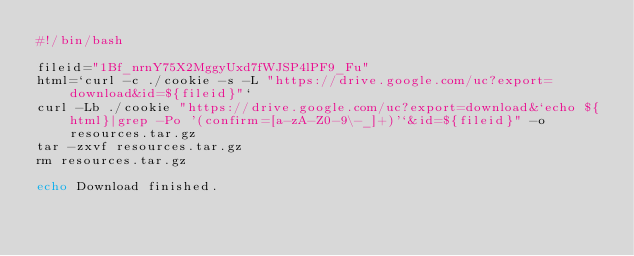<code> <loc_0><loc_0><loc_500><loc_500><_Bash_>#!/bin/bash

fileid="1Bf_nrnY75X2MggyUxd7fWJSP4lPF9_Fu"
html=`curl -c ./cookie -s -L "https://drive.google.com/uc?export=download&id=${fileid}"`
curl -Lb ./cookie "https://drive.google.com/uc?export=download&`echo ${html}|grep -Po '(confirm=[a-zA-Z0-9\-_]+)'`&id=${fileid}" -o resources.tar.gz
tar -zxvf resources.tar.gz
rm resources.tar.gz

echo Download finished.
</code> 